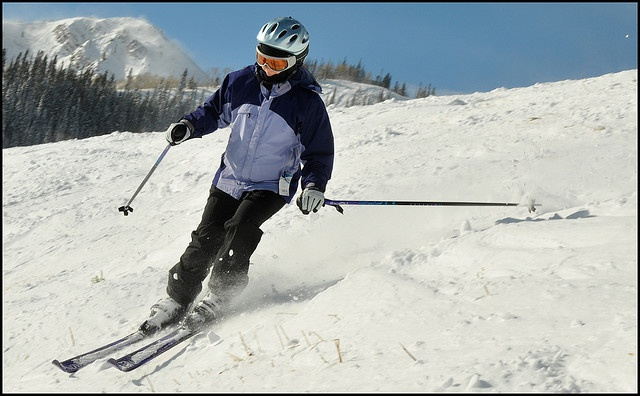Describe the objects in this image and their specific colors. I can see people in black, gray, and darkgray tones and skis in black, darkgray, gray, and lightgray tones in this image. 